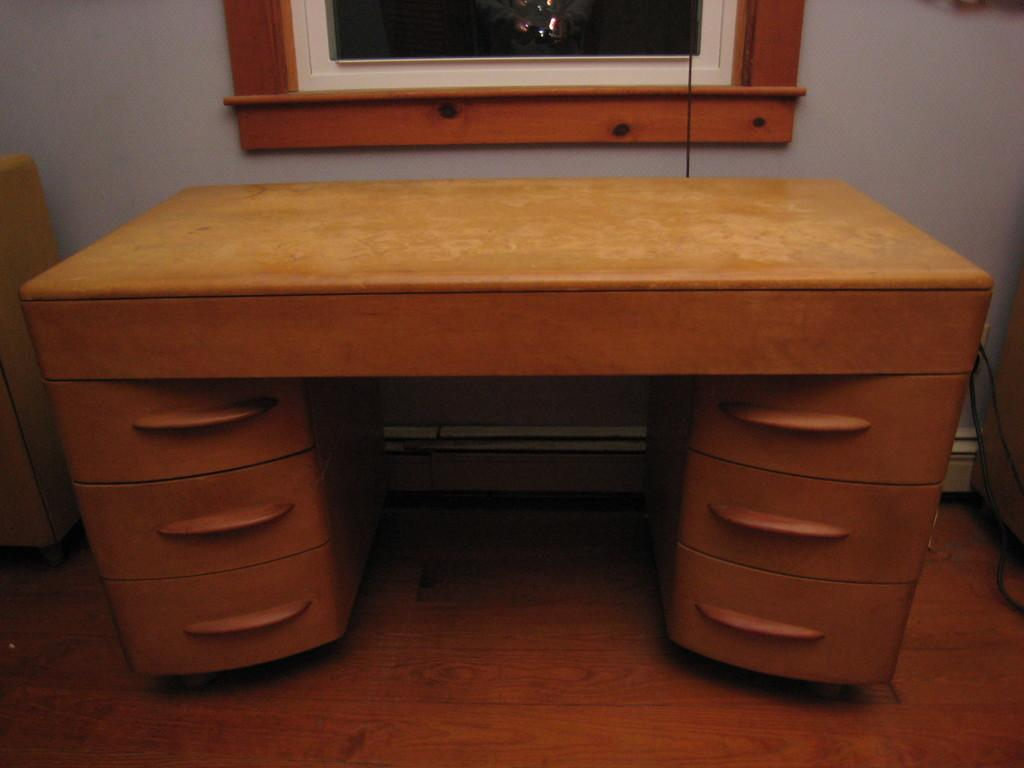What is the main object in the image? There is a disk in the image. Can you describe the disk's structure? The disk has three shelves on each side. What type of vest is the office manager wearing in the image? There is no office manager or vest present in the image; it only features a disk with three shelves on each side. 